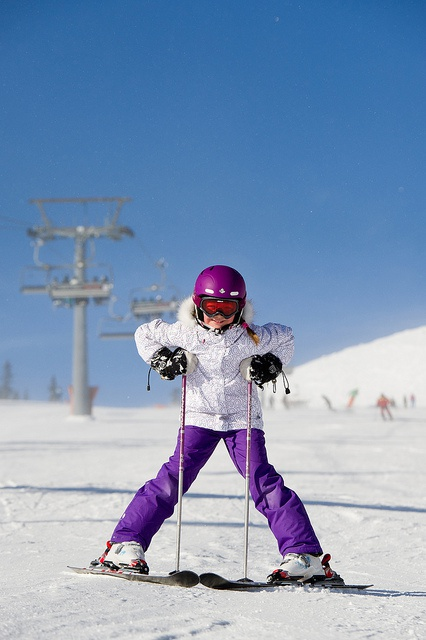Describe the objects in this image and their specific colors. I can see people in blue, lightgray, darkgray, navy, and black tones, skis in blue, black, gray, lightgray, and darkgray tones, people in blue and gray tones, people in blue, darkgray, lightpink, and salmon tones, and people in blue, lightgray, and darkgray tones in this image. 